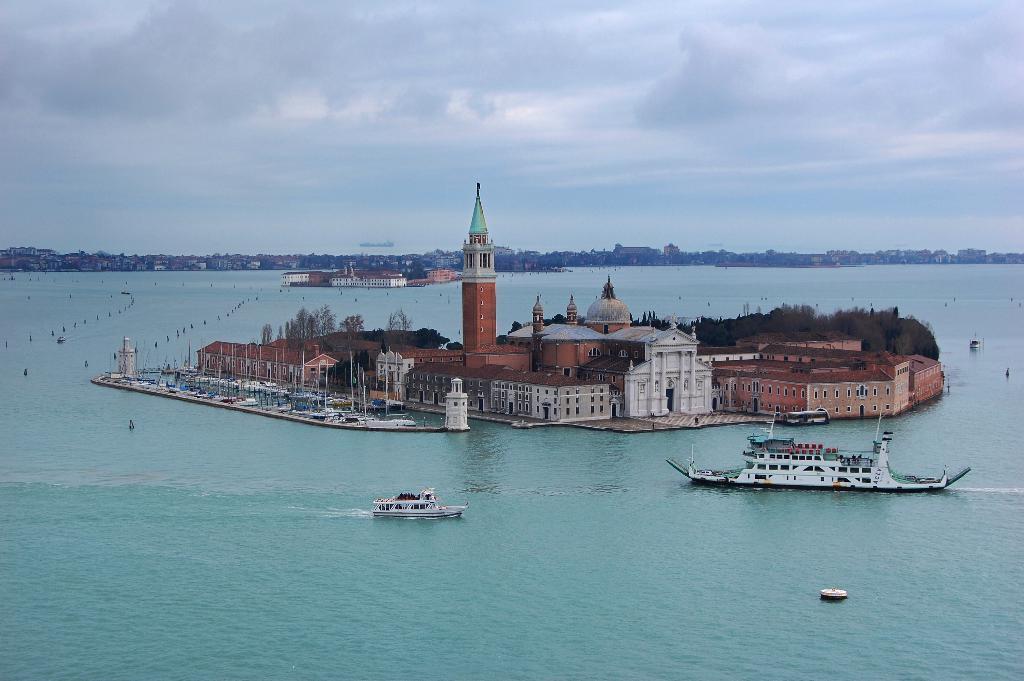Could you give a brief overview of what you see in this image? In this image we can see there are buildings, trees, boats, ships on the water. And at the back there are buildings and the sky. 